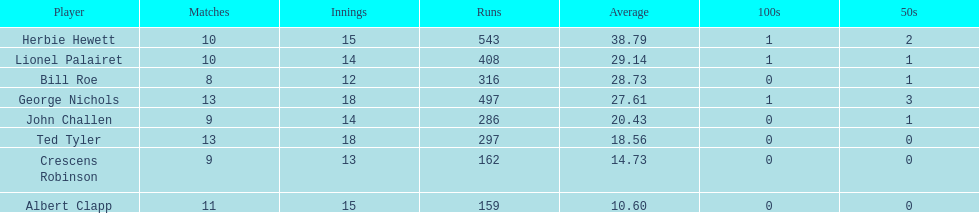How many more runs does john have than albert? 127. Can you parse all the data within this table? {'header': ['Player', 'Matches', 'Innings', 'Runs', 'Average', '100s', '50s'], 'rows': [['Herbie Hewett', '10', '15', '543', '38.79', '1', '2'], ['Lionel Palairet', '10', '14', '408', '29.14', '1', '1'], ['Bill Roe', '8', '12', '316', '28.73', '0', '1'], ['George Nichols', '13', '18', '497', '27.61', '1', '3'], ['John Challen', '9', '14', '286', '20.43', '0', '1'], ['Ted Tyler', '13', '18', '297', '18.56', '0', '0'], ['Crescens Robinson', '9', '13', '162', '14.73', '0', '0'], ['Albert Clapp', '11', '15', '159', '10.60', '0', '0']]} 